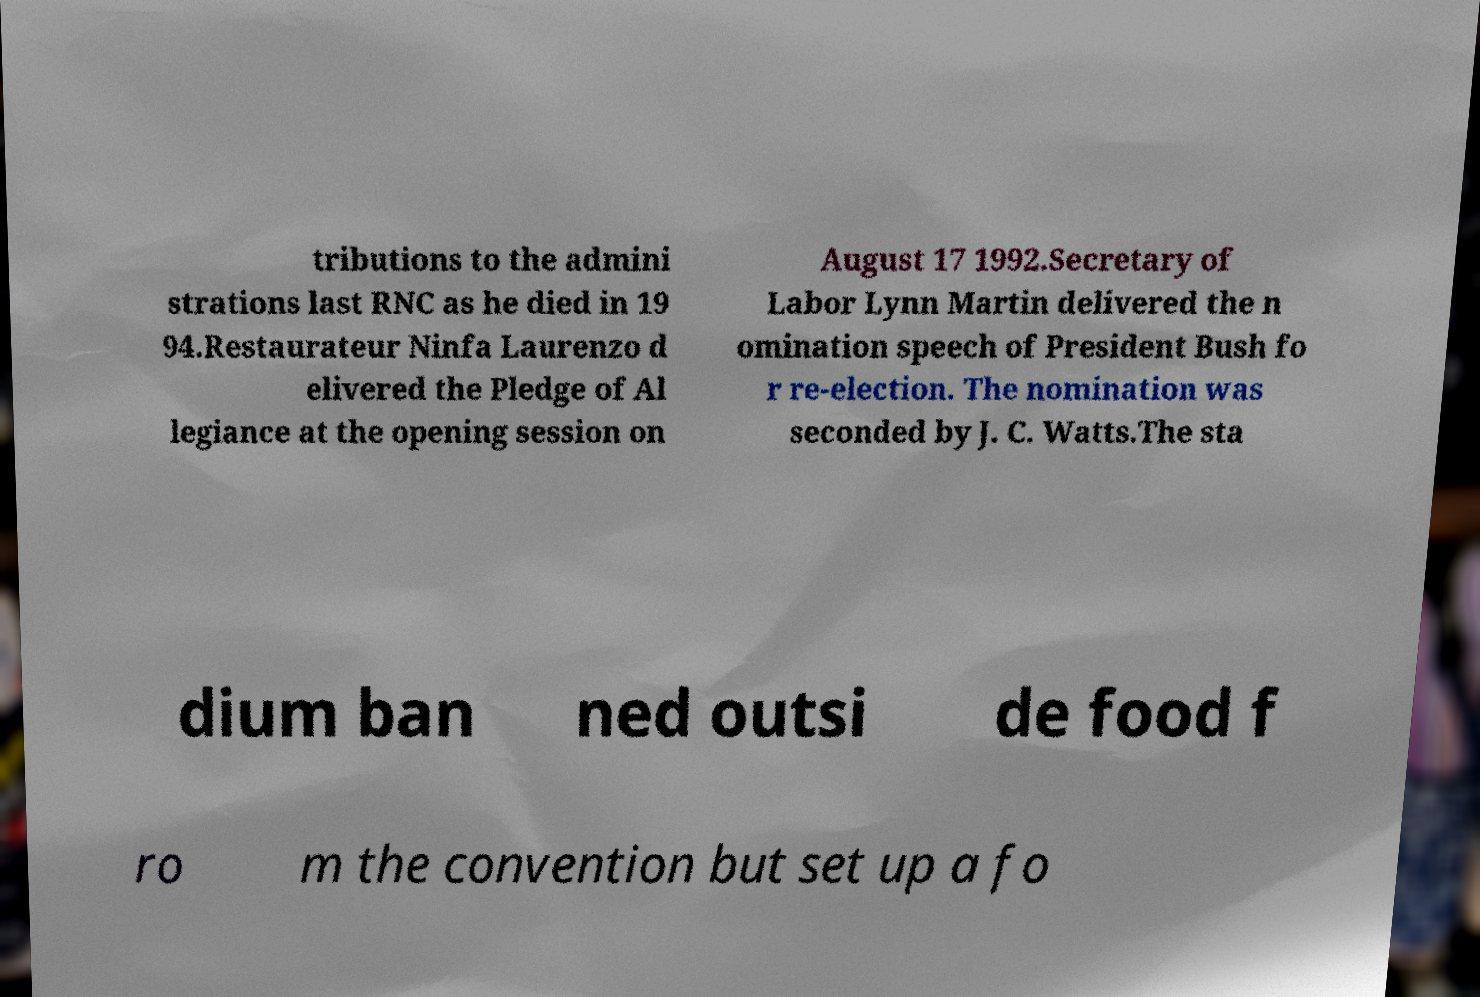Can you read and provide the text displayed in the image?This photo seems to have some interesting text. Can you extract and type it out for me? tributions to the admini strations last RNC as he died in 19 94.Restaurateur Ninfa Laurenzo d elivered the Pledge of Al legiance at the opening session on August 17 1992.Secretary of Labor Lynn Martin delivered the n omination speech of President Bush fo r re-election. The nomination was seconded by J. C. Watts.The sta dium ban ned outsi de food f ro m the convention but set up a fo 